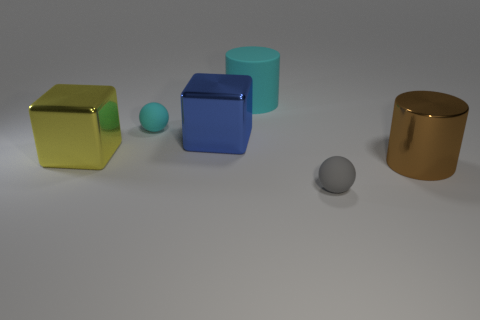What color is the large metal cube on the right side of the rubber object left of the big cylinder that is to the left of the small gray thing?
Provide a succinct answer. Blue. There is a large metallic thing that is both to the left of the big brown thing and right of the yellow object; what is its shape?
Offer a very short reply. Cube. Are there any other things that are the same size as the gray rubber sphere?
Make the answer very short. Yes. The tiny matte ball that is behind the small thing in front of the tiny cyan rubber ball is what color?
Make the answer very short. Cyan. There is a tiny object that is on the left side of the cyan rubber object right of the tiny ball that is on the left side of the big blue thing; what shape is it?
Provide a succinct answer. Sphere. What size is the metallic object that is on the right side of the big yellow object and left of the tiny gray matte object?
Provide a succinct answer. Large. What number of big metal cylinders have the same color as the large rubber object?
Offer a terse response. 0. What is the material of the object that is the same color as the matte cylinder?
Offer a terse response. Rubber. What is the material of the yellow cube?
Offer a very short reply. Metal. Does the cube right of the cyan ball have the same material as the big brown cylinder?
Provide a short and direct response. Yes. 